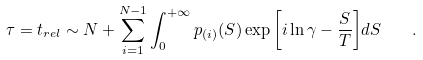<formula> <loc_0><loc_0><loc_500><loc_500>\tau = t _ { r e l } \sim N + \sum _ { i = 1 } ^ { N - 1 } \int _ { 0 } ^ { + \infty } p _ { ( i ) } ( S ) \exp { \left [ i \ln { \gamma } - \frac { S } { T } \right ] } d S \quad .</formula> 